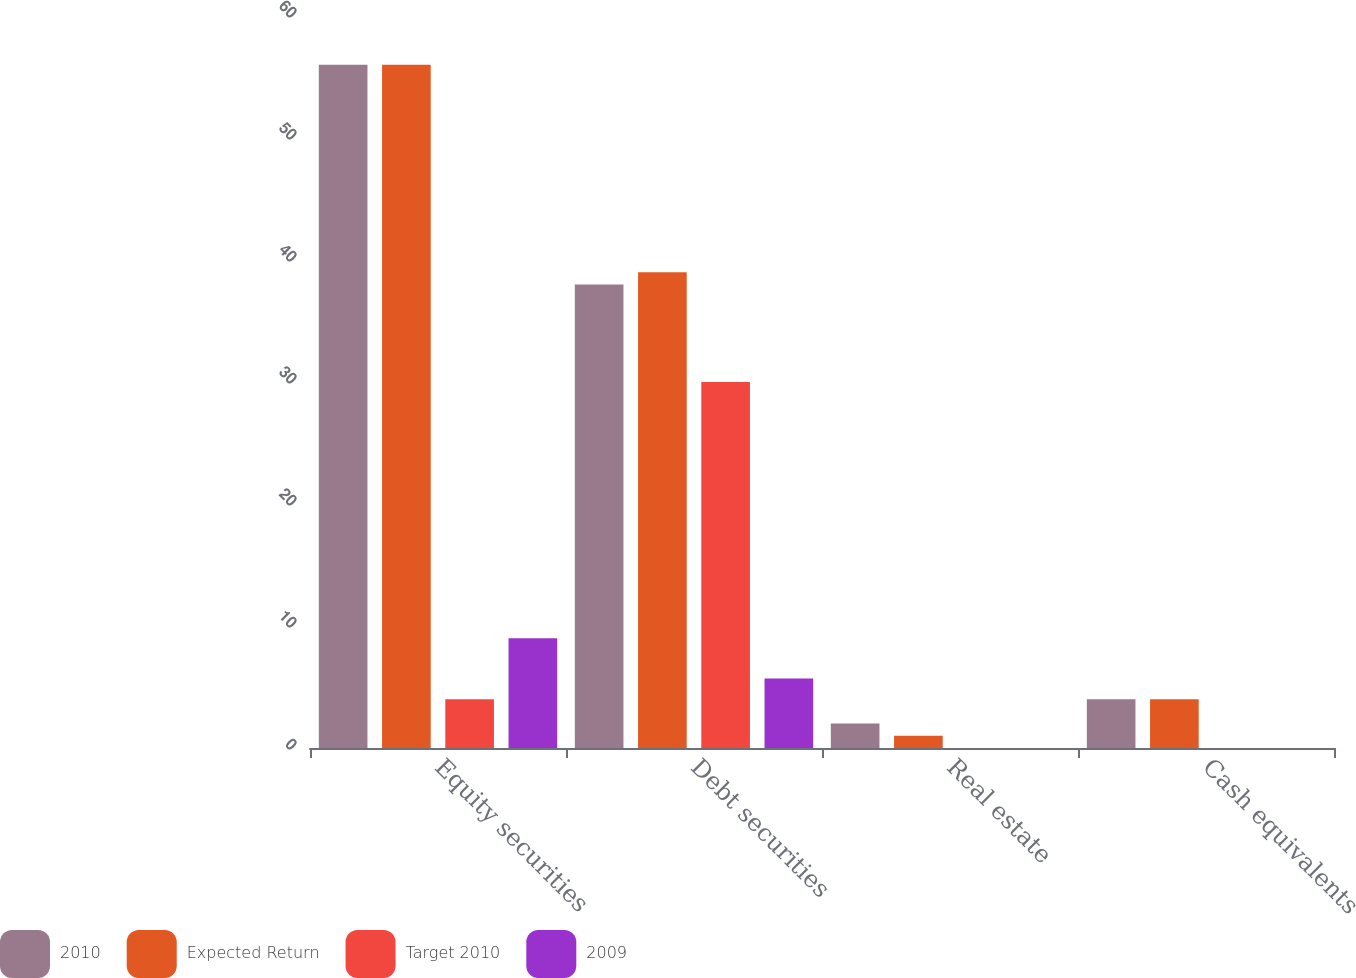Convert chart. <chart><loc_0><loc_0><loc_500><loc_500><stacked_bar_chart><ecel><fcel>Equity securities<fcel>Debt securities<fcel>Real estate<fcel>Cash equivalents<nl><fcel>2010<fcel>56<fcel>38<fcel>2<fcel>4<nl><fcel>Expected Return<fcel>56<fcel>39<fcel>1<fcel>4<nl><fcel>Target 2010<fcel>4<fcel>30<fcel>0<fcel>0<nl><fcel>2009<fcel>9<fcel>5.7<fcel>0<fcel>0<nl></chart> 